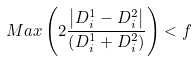Convert formula to latex. <formula><loc_0><loc_0><loc_500><loc_500>M a x \left ( 2 \frac { \left | D ^ { 1 } _ { i } - D ^ { 2 } _ { i } \right | } { \left ( D ^ { 1 } _ { i } + D ^ { 2 } _ { i } \right ) } \right ) < f</formula> 